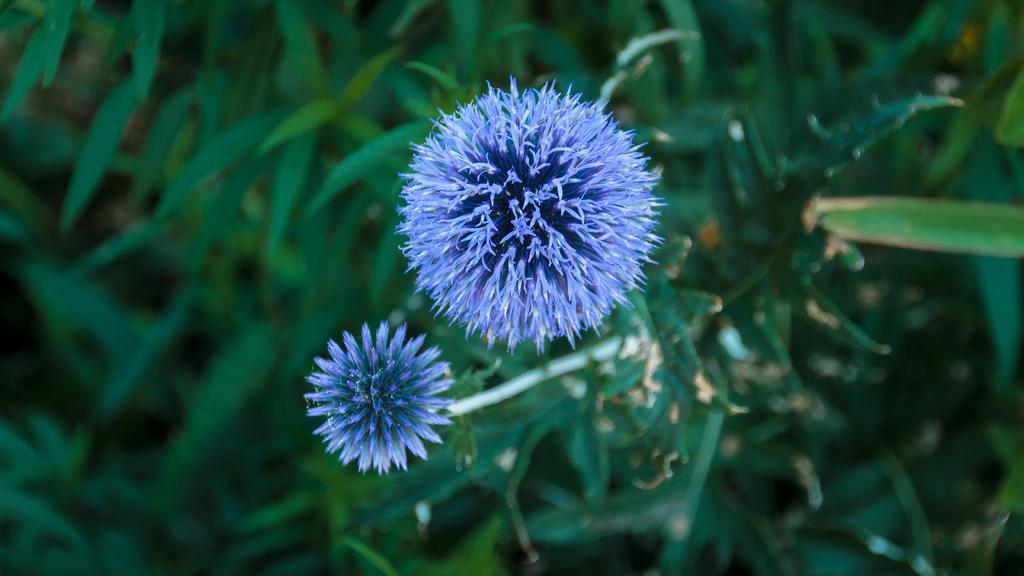What type of living organisms can be seen in the image? Plants and flowers can be seen in the image. What color are the flowers in the image? The flowers in the image are in violet color. What type of beef is being served for lunch in the image? There is no beef or lunch present in the image; it features plants and flowers. What flavor of cake can be seen in the image? There is no cake present in the image; it features plants and flowers. 